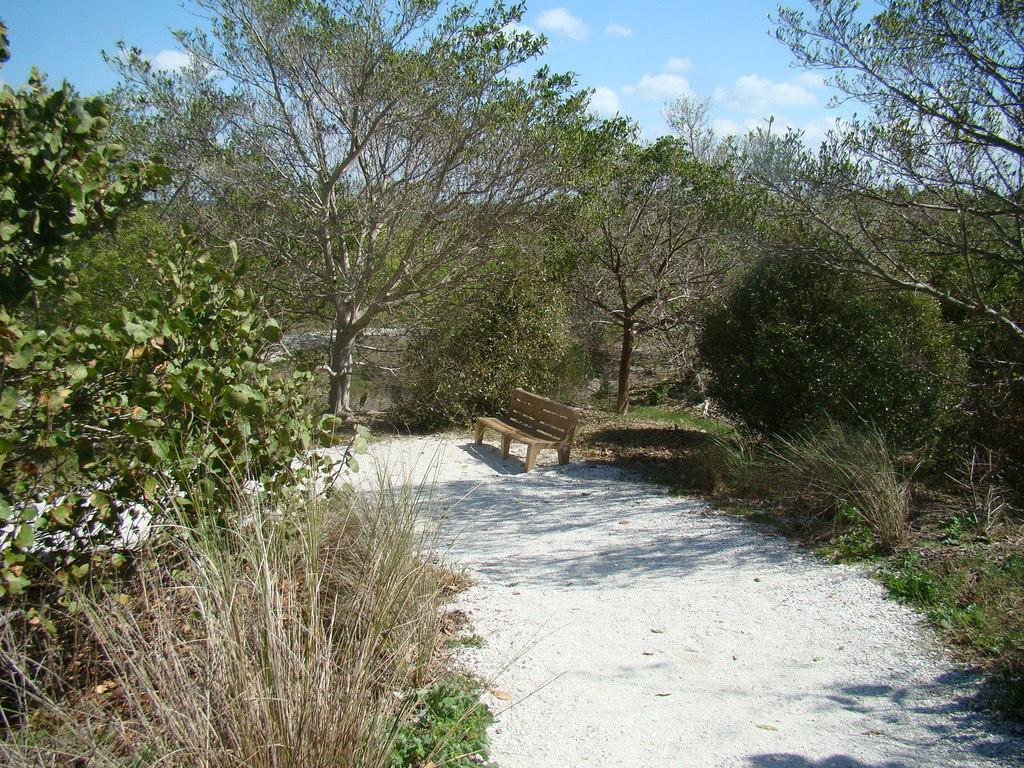What is at the bottom of the image? There is white sand at the bottom of the image. What is located on the white sand? There is a bench on the white sand. What type of vegetation can be seen in the image? There are trees in the image. What is visible at the top of the image? The sky is visible at the top of the image. What can be seen in the background of the sky? There are clouds in the background of the sky. What type of chain can be seen hanging from the trees in the image? There is no chain present in the image; it features white sand, a bench, trees, and a sky with clouds. What kind of bean is growing on the bench in the image? There are no beans present in the image; it features white sand, a bench, trees, and a sky with clouds. 